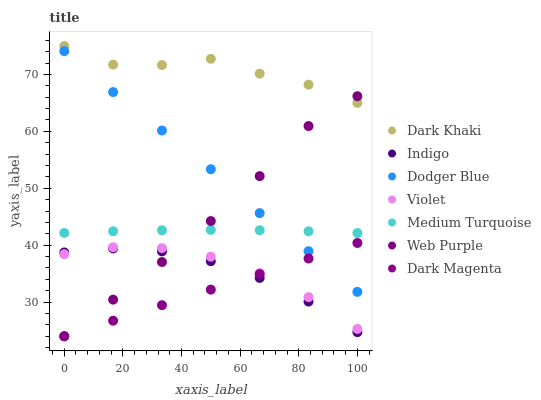Does Dark Magenta have the minimum area under the curve?
Answer yes or no. Yes. Does Dark Khaki have the maximum area under the curve?
Answer yes or no. Yes. Does Dark Khaki have the minimum area under the curve?
Answer yes or no. No. Does Dark Magenta have the maximum area under the curve?
Answer yes or no. No. Is Dark Magenta the smoothest?
Answer yes or no. Yes. Is Dark Khaki the roughest?
Answer yes or no. Yes. Is Dark Khaki the smoothest?
Answer yes or no. No. Is Dark Magenta the roughest?
Answer yes or no. No. Does Dark Magenta have the lowest value?
Answer yes or no. Yes. Does Dark Khaki have the lowest value?
Answer yes or no. No. Does Dark Khaki have the highest value?
Answer yes or no. Yes. Does Dark Magenta have the highest value?
Answer yes or no. No. Is Indigo less than Dark Khaki?
Answer yes or no. Yes. Is Dark Khaki greater than Dark Magenta?
Answer yes or no. Yes. Does Web Purple intersect Dark Magenta?
Answer yes or no. Yes. Is Web Purple less than Dark Magenta?
Answer yes or no. No. Is Web Purple greater than Dark Magenta?
Answer yes or no. No. Does Indigo intersect Dark Khaki?
Answer yes or no. No. 